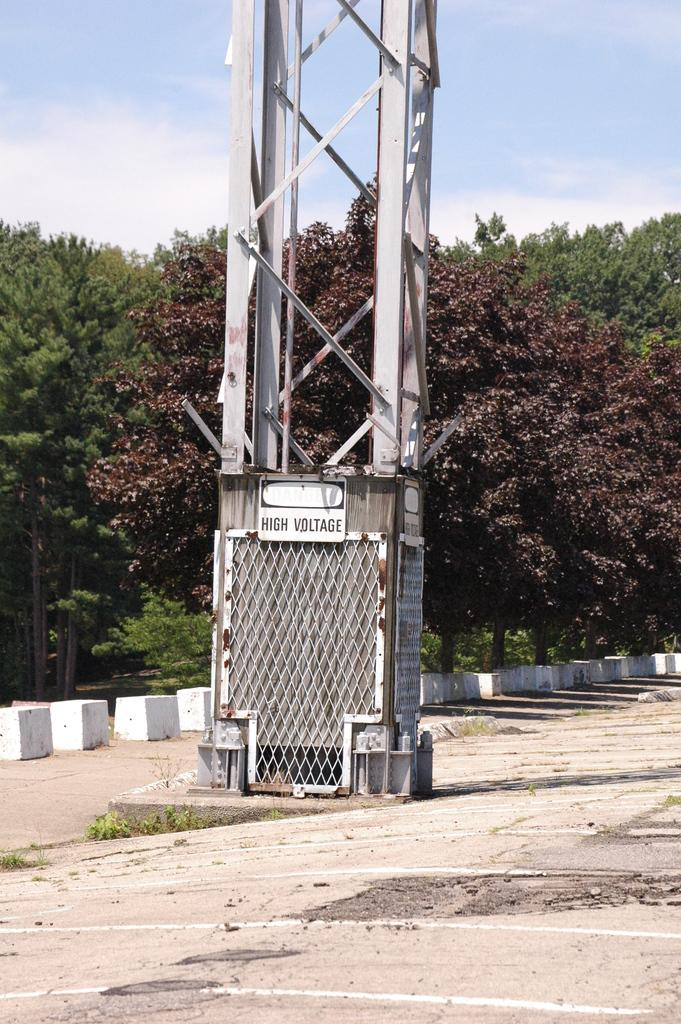What structure is featured in the image with a board attached to it? There is a tower with a board in the image. What can be seen at the bottom of the image? There is a pathway at the bottom of the image. What type of natural elements are present in the image? There are rocks and trees in the image. What is visible in the background of the image? The sky is visible in the background of the image. Can you describe the frog's activity on the board in the image? There is no frog present in the image, so it is not possible to describe its activity on the board. 